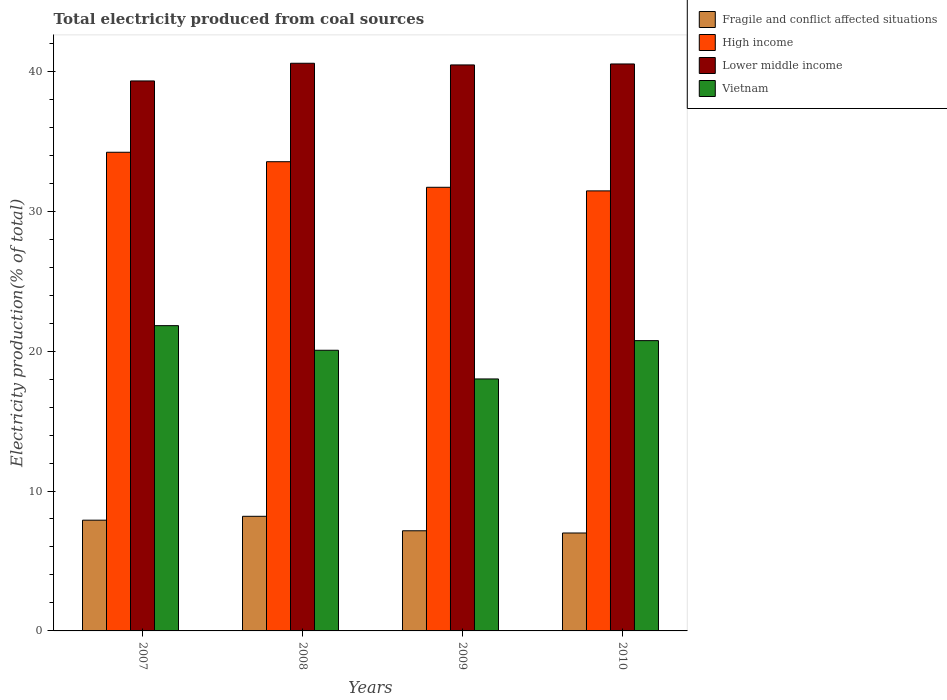How many different coloured bars are there?
Make the answer very short. 4. Are the number of bars per tick equal to the number of legend labels?
Your answer should be very brief. Yes. How many bars are there on the 3rd tick from the right?
Your response must be concise. 4. What is the label of the 2nd group of bars from the left?
Make the answer very short. 2008. In how many cases, is the number of bars for a given year not equal to the number of legend labels?
Your answer should be very brief. 0. What is the total electricity produced in Vietnam in 2009?
Your response must be concise. 18.01. Across all years, what is the maximum total electricity produced in Fragile and conflict affected situations?
Your response must be concise. 8.19. Across all years, what is the minimum total electricity produced in Lower middle income?
Offer a very short reply. 39.31. In which year was the total electricity produced in High income minimum?
Make the answer very short. 2010. What is the total total electricity produced in High income in the graph?
Make the answer very short. 130.9. What is the difference between the total electricity produced in Fragile and conflict affected situations in 2007 and that in 2008?
Give a very brief answer. -0.28. What is the difference between the total electricity produced in High income in 2007 and the total electricity produced in Vietnam in 2009?
Give a very brief answer. 16.2. What is the average total electricity produced in Lower middle income per year?
Your answer should be very brief. 40.21. In the year 2009, what is the difference between the total electricity produced in Fragile and conflict affected situations and total electricity produced in Vietnam?
Your answer should be very brief. -10.85. In how many years, is the total electricity produced in Fragile and conflict affected situations greater than 14 %?
Offer a very short reply. 0. What is the ratio of the total electricity produced in Vietnam in 2008 to that in 2010?
Your answer should be very brief. 0.97. What is the difference between the highest and the second highest total electricity produced in High income?
Provide a short and direct response. 0.68. What is the difference between the highest and the lowest total electricity produced in High income?
Make the answer very short. 2.76. What does the 4th bar from the left in 2007 represents?
Provide a short and direct response. Vietnam. What does the 3rd bar from the right in 2008 represents?
Provide a succinct answer. High income. Is it the case that in every year, the sum of the total electricity produced in Fragile and conflict affected situations and total electricity produced in Lower middle income is greater than the total electricity produced in Vietnam?
Your answer should be compact. Yes. How many bars are there?
Your response must be concise. 16. Are all the bars in the graph horizontal?
Offer a very short reply. No. How many years are there in the graph?
Your answer should be very brief. 4. What is the difference between two consecutive major ticks on the Y-axis?
Offer a very short reply. 10. Are the values on the major ticks of Y-axis written in scientific E-notation?
Ensure brevity in your answer.  No. Does the graph contain any zero values?
Keep it short and to the point. No. How many legend labels are there?
Offer a terse response. 4. How are the legend labels stacked?
Your response must be concise. Vertical. What is the title of the graph?
Offer a terse response. Total electricity produced from coal sources. What is the label or title of the X-axis?
Offer a terse response. Years. What is the label or title of the Y-axis?
Offer a terse response. Electricity production(% of total). What is the Electricity production(% of total) of Fragile and conflict affected situations in 2007?
Ensure brevity in your answer.  7.91. What is the Electricity production(% of total) in High income in 2007?
Provide a succinct answer. 34.21. What is the Electricity production(% of total) in Lower middle income in 2007?
Keep it short and to the point. 39.31. What is the Electricity production(% of total) in Vietnam in 2007?
Your answer should be very brief. 21.82. What is the Electricity production(% of total) in Fragile and conflict affected situations in 2008?
Offer a very short reply. 8.19. What is the Electricity production(% of total) in High income in 2008?
Your response must be concise. 33.54. What is the Electricity production(% of total) of Lower middle income in 2008?
Ensure brevity in your answer.  40.57. What is the Electricity production(% of total) in Vietnam in 2008?
Your answer should be very brief. 20.06. What is the Electricity production(% of total) in Fragile and conflict affected situations in 2009?
Your response must be concise. 7.16. What is the Electricity production(% of total) of High income in 2009?
Your answer should be very brief. 31.71. What is the Electricity production(% of total) in Lower middle income in 2009?
Make the answer very short. 40.45. What is the Electricity production(% of total) of Vietnam in 2009?
Offer a terse response. 18.01. What is the Electricity production(% of total) in Fragile and conflict affected situations in 2010?
Give a very brief answer. 7. What is the Electricity production(% of total) of High income in 2010?
Provide a short and direct response. 31.45. What is the Electricity production(% of total) in Lower middle income in 2010?
Provide a short and direct response. 40.52. What is the Electricity production(% of total) in Vietnam in 2010?
Offer a terse response. 20.75. Across all years, what is the maximum Electricity production(% of total) in Fragile and conflict affected situations?
Your answer should be very brief. 8.19. Across all years, what is the maximum Electricity production(% of total) of High income?
Your response must be concise. 34.21. Across all years, what is the maximum Electricity production(% of total) in Lower middle income?
Ensure brevity in your answer.  40.57. Across all years, what is the maximum Electricity production(% of total) in Vietnam?
Offer a very short reply. 21.82. Across all years, what is the minimum Electricity production(% of total) in Fragile and conflict affected situations?
Keep it short and to the point. 7. Across all years, what is the minimum Electricity production(% of total) of High income?
Your answer should be very brief. 31.45. Across all years, what is the minimum Electricity production(% of total) in Lower middle income?
Your answer should be very brief. 39.31. Across all years, what is the minimum Electricity production(% of total) in Vietnam?
Make the answer very short. 18.01. What is the total Electricity production(% of total) of Fragile and conflict affected situations in the graph?
Your answer should be compact. 30.26. What is the total Electricity production(% of total) in High income in the graph?
Your answer should be compact. 130.9. What is the total Electricity production(% of total) of Lower middle income in the graph?
Give a very brief answer. 160.86. What is the total Electricity production(% of total) of Vietnam in the graph?
Ensure brevity in your answer.  80.63. What is the difference between the Electricity production(% of total) of Fragile and conflict affected situations in 2007 and that in 2008?
Offer a very short reply. -0.28. What is the difference between the Electricity production(% of total) in High income in 2007 and that in 2008?
Offer a very short reply. 0.68. What is the difference between the Electricity production(% of total) in Lower middle income in 2007 and that in 2008?
Your answer should be compact. -1.26. What is the difference between the Electricity production(% of total) of Vietnam in 2007 and that in 2008?
Offer a very short reply. 1.76. What is the difference between the Electricity production(% of total) in Fragile and conflict affected situations in 2007 and that in 2009?
Provide a succinct answer. 0.76. What is the difference between the Electricity production(% of total) in High income in 2007 and that in 2009?
Ensure brevity in your answer.  2.5. What is the difference between the Electricity production(% of total) in Lower middle income in 2007 and that in 2009?
Keep it short and to the point. -1.15. What is the difference between the Electricity production(% of total) of Vietnam in 2007 and that in 2009?
Offer a terse response. 3.81. What is the difference between the Electricity production(% of total) of Fragile and conflict affected situations in 2007 and that in 2010?
Offer a very short reply. 0.92. What is the difference between the Electricity production(% of total) in High income in 2007 and that in 2010?
Your answer should be compact. 2.76. What is the difference between the Electricity production(% of total) of Lower middle income in 2007 and that in 2010?
Offer a terse response. -1.21. What is the difference between the Electricity production(% of total) in Vietnam in 2007 and that in 2010?
Your answer should be very brief. 1.07. What is the difference between the Electricity production(% of total) in Fragile and conflict affected situations in 2008 and that in 2009?
Provide a short and direct response. 1.03. What is the difference between the Electricity production(% of total) in High income in 2008 and that in 2009?
Make the answer very short. 1.83. What is the difference between the Electricity production(% of total) of Lower middle income in 2008 and that in 2009?
Give a very brief answer. 0.12. What is the difference between the Electricity production(% of total) of Vietnam in 2008 and that in 2009?
Your answer should be compact. 2.05. What is the difference between the Electricity production(% of total) of Fragile and conflict affected situations in 2008 and that in 2010?
Your answer should be compact. 1.19. What is the difference between the Electricity production(% of total) of High income in 2008 and that in 2010?
Make the answer very short. 2.08. What is the difference between the Electricity production(% of total) of Lower middle income in 2008 and that in 2010?
Provide a short and direct response. 0.05. What is the difference between the Electricity production(% of total) in Vietnam in 2008 and that in 2010?
Offer a terse response. -0.69. What is the difference between the Electricity production(% of total) in Fragile and conflict affected situations in 2009 and that in 2010?
Keep it short and to the point. 0.16. What is the difference between the Electricity production(% of total) in High income in 2009 and that in 2010?
Your response must be concise. 0.26. What is the difference between the Electricity production(% of total) in Lower middle income in 2009 and that in 2010?
Your response must be concise. -0.07. What is the difference between the Electricity production(% of total) of Vietnam in 2009 and that in 2010?
Keep it short and to the point. -2.74. What is the difference between the Electricity production(% of total) in Fragile and conflict affected situations in 2007 and the Electricity production(% of total) in High income in 2008?
Your answer should be compact. -25.62. What is the difference between the Electricity production(% of total) in Fragile and conflict affected situations in 2007 and the Electricity production(% of total) in Lower middle income in 2008?
Offer a very short reply. -32.66. What is the difference between the Electricity production(% of total) in Fragile and conflict affected situations in 2007 and the Electricity production(% of total) in Vietnam in 2008?
Your answer should be very brief. -12.14. What is the difference between the Electricity production(% of total) of High income in 2007 and the Electricity production(% of total) of Lower middle income in 2008?
Your answer should be compact. -6.36. What is the difference between the Electricity production(% of total) of High income in 2007 and the Electricity production(% of total) of Vietnam in 2008?
Offer a very short reply. 14.15. What is the difference between the Electricity production(% of total) in Lower middle income in 2007 and the Electricity production(% of total) in Vietnam in 2008?
Make the answer very short. 19.25. What is the difference between the Electricity production(% of total) in Fragile and conflict affected situations in 2007 and the Electricity production(% of total) in High income in 2009?
Make the answer very short. -23.79. What is the difference between the Electricity production(% of total) of Fragile and conflict affected situations in 2007 and the Electricity production(% of total) of Lower middle income in 2009?
Make the answer very short. -32.54. What is the difference between the Electricity production(% of total) in Fragile and conflict affected situations in 2007 and the Electricity production(% of total) in Vietnam in 2009?
Your answer should be compact. -10.09. What is the difference between the Electricity production(% of total) of High income in 2007 and the Electricity production(% of total) of Lower middle income in 2009?
Your answer should be compact. -6.24. What is the difference between the Electricity production(% of total) of High income in 2007 and the Electricity production(% of total) of Vietnam in 2009?
Offer a very short reply. 16.2. What is the difference between the Electricity production(% of total) of Lower middle income in 2007 and the Electricity production(% of total) of Vietnam in 2009?
Provide a succinct answer. 21.3. What is the difference between the Electricity production(% of total) in Fragile and conflict affected situations in 2007 and the Electricity production(% of total) in High income in 2010?
Provide a succinct answer. -23.54. What is the difference between the Electricity production(% of total) of Fragile and conflict affected situations in 2007 and the Electricity production(% of total) of Lower middle income in 2010?
Your answer should be very brief. -32.61. What is the difference between the Electricity production(% of total) in Fragile and conflict affected situations in 2007 and the Electricity production(% of total) in Vietnam in 2010?
Provide a short and direct response. -12.83. What is the difference between the Electricity production(% of total) of High income in 2007 and the Electricity production(% of total) of Lower middle income in 2010?
Provide a succinct answer. -6.31. What is the difference between the Electricity production(% of total) in High income in 2007 and the Electricity production(% of total) in Vietnam in 2010?
Give a very brief answer. 13.46. What is the difference between the Electricity production(% of total) of Lower middle income in 2007 and the Electricity production(% of total) of Vietnam in 2010?
Keep it short and to the point. 18.56. What is the difference between the Electricity production(% of total) in Fragile and conflict affected situations in 2008 and the Electricity production(% of total) in High income in 2009?
Make the answer very short. -23.52. What is the difference between the Electricity production(% of total) of Fragile and conflict affected situations in 2008 and the Electricity production(% of total) of Lower middle income in 2009?
Your response must be concise. -32.26. What is the difference between the Electricity production(% of total) in Fragile and conflict affected situations in 2008 and the Electricity production(% of total) in Vietnam in 2009?
Provide a short and direct response. -9.82. What is the difference between the Electricity production(% of total) of High income in 2008 and the Electricity production(% of total) of Lower middle income in 2009?
Keep it short and to the point. -6.92. What is the difference between the Electricity production(% of total) of High income in 2008 and the Electricity production(% of total) of Vietnam in 2009?
Your answer should be compact. 15.53. What is the difference between the Electricity production(% of total) in Lower middle income in 2008 and the Electricity production(% of total) in Vietnam in 2009?
Offer a very short reply. 22.56. What is the difference between the Electricity production(% of total) in Fragile and conflict affected situations in 2008 and the Electricity production(% of total) in High income in 2010?
Offer a terse response. -23.26. What is the difference between the Electricity production(% of total) in Fragile and conflict affected situations in 2008 and the Electricity production(% of total) in Lower middle income in 2010?
Your answer should be very brief. -32.33. What is the difference between the Electricity production(% of total) of Fragile and conflict affected situations in 2008 and the Electricity production(% of total) of Vietnam in 2010?
Ensure brevity in your answer.  -12.56. What is the difference between the Electricity production(% of total) in High income in 2008 and the Electricity production(% of total) in Lower middle income in 2010?
Provide a short and direct response. -6.99. What is the difference between the Electricity production(% of total) of High income in 2008 and the Electricity production(% of total) of Vietnam in 2010?
Your answer should be very brief. 12.79. What is the difference between the Electricity production(% of total) in Lower middle income in 2008 and the Electricity production(% of total) in Vietnam in 2010?
Your response must be concise. 19.82. What is the difference between the Electricity production(% of total) in Fragile and conflict affected situations in 2009 and the Electricity production(% of total) in High income in 2010?
Give a very brief answer. -24.29. What is the difference between the Electricity production(% of total) of Fragile and conflict affected situations in 2009 and the Electricity production(% of total) of Lower middle income in 2010?
Give a very brief answer. -33.36. What is the difference between the Electricity production(% of total) of Fragile and conflict affected situations in 2009 and the Electricity production(% of total) of Vietnam in 2010?
Make the answer very short. -13.59. What is the difference between the Electricity production(% of total) of High income in 2009 and the Electricity production(% of total) of Lower middle income in 2010?
Your response must be concise. -8.81. What is the difference between the Electricity production(% of total) of High income in 2009 and the Electricity production(% of total) of Vietnam in 2010?
Your answer should be compact. 10.96. What is the difference between the Electricity production(% of total) of Lower middle income in 2009 and the Electricity production(% of total) of Vietnam in 2010?
Your answer should be very brief. 19.71. What is the average Electricity production(% of total) in Fragile and conflict affected situations per year?
Offer a terse response. 7.57. What is the average Electricity production(% of total) of High income per year?
Provide a succinct answer. 32.73. What is the average Electricity production(% of total) of Lower middle income per year?
Make the answer very short. 40.21. What is the average Electricity production(% of total) in Vietnam per year?
Your response must be concise. 20.16. In the year 2007, what is the difference between the Electricity production(% of total) of Fragile and conflict affected situations and Electricity production(% of total) of High income?
Your answer should be very brief. -26.3. In the year 2007, what is the difference between the Electricity production(% of total) in Fragile and conflict affected situations and Electricity production(% of total) in Lower middle income?
Give a very brief answer. -31.39. In the year 2007, what is the difference between the Electricity production(% of total) in Fragile and conflict affected situations and Electricity production(% of total) in Vietnam?
Keep it short and to the point. -13.9. In the year 2007, what is the difference between the Electricity production(% of total) in High income and Electricity production(% of total) in Lower middle income?
Provide a short and direct response. -5.1. In the year 2007, what is the difference between the Electricity production(% of total) of High income and Electricity production(% of total) of Vietnam?
Ensure brevity in your answer.  12.39. In the year 2007, what is the difference between the Electricity production(% of total) of Lower middle income and Electricity production(% of total) of Vietnam?
Give a very brief answer. 17.49. In the year 2008, what is the difference between the Electricity production(% of total) in Fragile and conflict affected situations and Electricity production(% of total) in High income?
Provide a succinct answer. -25.34. In the year 2008, what is the difference between the Electricity production(% of total) of Fragile and conflict affected situations and Electricity production(% of total) of Lower middle income?
Make the answer very short. -32.38. In the year 2008, what is the difference between the Electricity production(% of total) in Fragile and conflict affected situations and Electricity production(% of total) in Vietnam?
Make the answer very short. -11.87. In the year 2008, what is the difference between the Electricity production(% of total) in High income and Electricity production(% of total) in Lower middle income?
Keep it short and to the point. -7.04. In the year 2008, what is the difference between the Electricity production(% of total) of High income and Electricity production(% of total) of Vietnam?
Provide a succinct answer. 13.48. In the year 2008, what is the difference between the Electricity production(% of total) in Lower middle income and Electricity production(% of total) in Vietnam?
Make the answer very short. 20.51. In the year 2009, what is the difference between the Electricity production(% of total) of Fragile and conflict affected situations and Electricity production(% of total) of High income?
Keep it short and to the point. -24.55. In the year 2009, what is the difference between the Electricity production(% of total) of Fragile and conflict affected situations and Electricity production(% of total) of Lower middle income?
Your answer should be compact. -33.3. In the year 2009, what is the difference between the Electricity production(% of total) in Fragile and conflict affected situations and Electricity production(% of total) in Vietnam?
Ensure brevity in your answer.  -10.85. In the year 2009, what is the difference between the Electricity production(% of total) in High income and Electricity production(% of total) in Lower middle income?
Offer a very short reply. -8.75. In the year 2009, what is the difference between the Electricity production(% of total) of High income and Electricity production(% of total) of Vietnam?
Provide a succinct answer. 13.7. In the year 2009, what is the difference between the Electricity production(% of total) in Lower middle income and Electricity production(% of total) in Vietnam?
Your response must be concise. 22.44. In the year 2010, what is the difference between the Electricity production(% of total) of Fragile and conflict affected situations and Electricity production(% of total) of High income?
Offer a very short reply. -24.45. In the year 2010, what is the difference between the Electricity production(% of total) in Fragile and conflict affected situations and Electricity production(% of total) in Lower middle income?
Your response must be concise. -33.52. In the year 2010, what is the difference between the Electricity production(% of total) in Fragile and conflict affected situations and Electricity production(% of total) in Vietnam?
Offer a terse response. -13.75. In the year 2010, what is the difference between the Electricity production(% of total) in High income and Electricity production(% of total) in Lower middle income?
Your response must be concise. -9.07. In the year 2010, what is the difference between the Electricity production(% of total) of High income and Electricity production(% of total) of Vietnam?
Make the answer very short. 10.7. In the year 2010, what is the difference between the Electricity production(% of total) of Lower middle income and Electricity production(% of total) of Vietnam?
Give a very brief answer. 19.77. What is the ratio of the Electricity production(% of total) in Fragile and conflict affected situations in 2007 to that in 2008?
Your answer should be compact. 0.97. What is the ratio of the Electricity production(% of total) of High income in 2007 to that in 2008?
Your answer should be compact. 1.02. What is the ratio of the Electricity production(% of total) in Lower middle income in 2007 to that in 2008?
Your response must be concise. 0.97. What is the ratio of the Electricity production(% of total) in Vietnam in 2007 to that in 2008?
Your response must be concise. 1.09. What is the ratio of the Electricity production(% of total) of Fragile and conflict affected situations in 2007 to that in 2009?
Keep it short and to the point. 1.11. What is the ratio of the Electricity production(% of total) of High income in 2007 to that in 2009?
Give a very brief answer. 1.08. What is the ratio of the Electricity production(% of total) in Lower middle income in 2007 to that in 2009?
Ensure brevity in your answer.  0.97. What is the ratio of the Electricity production(% of total) in Vietnam in 2007 to that in 2009?
Provide a succinct answer. 1.21. What is the ratio of the Electricity production(% of total) of Fragile and conflict affected situations in 2007 to that in 2010?
Provide a short and direct response. 1.13. What is the ratio of the Electricity production(% of total) of High income in 2007 to that in 2010?
Ensure brevity in your answer.  1.09. What is the ratio of the Electricity production(% of total) of Lower middle income in 2007 to that in 2010?
Ensure brevity in your answer.  0.97. What is the ratio of the Electricity production(% of total) of Vietnam in 2007 to that in 2010?
Give a very brief answer. 1.05. What is the ratio of the Electricity production(% of total) in Fragile and conflict affected situations in 2008 to that in 2009?
Make the answer very short. 1.14. What is the ratio of the Electricity production(% of total) of High income in 2008 to that in 2009?
Your answer should be very brief. 1.06. What is the ratio of the Electricity production(% of total) in Vietnam in 2008 to that in 2009?
Make the answer very short. 1.11. What is the ratio of the Electricity production(% of total) of Fragile and conflict affected situations in 2008 to that in 2010?
Your response must be concise. 1.17. What is the ratio of the Electricity production(% of total) in High income in 2008 to that in 2010?
Your response must be concise. 1.07. What is the ratio of the Electricity production(% of total) of Lower middle income in 2008 to that in 2010?
Your answer should be very brief. 1. What is the ratio of the Electricity production(% of total) of Vietnam in 2008 to that in 2010?
Offer a terse response. 0.97. What is the ratio of the Electricity production(% of total) in Fragile and conflict affected situations in 2009 to that in 2010?
Offer a very short reply. 1.02. What is the ratio of the Electricity production(% of total) in High income in 2009 to that in 2010?
Provide a succinct answer. 1.01. What is the ratio of the Electricity production(% of total) in Vietnam in 2009 to that in 2010?
Give a very brief answer. 0.87. What is the difference between the highest and the second highest Electricity production(% of total) in Fragile and conflict affected situations?
Your answer should be very brief. 0.28. What is the difference between the highest and the second highest Electricity production(% of total) in High income?
Your answer should be compact. 0.68. What is the difference between the highest and the second highest Electricity production(% of total) in Lower middle income?
Your answer should be compact. 0.05. What is the difference between the highest and the second highest Electricity production(% of total) in Vietnam?
Provide a short and direct response. 1.07. What is the difference between the highest and the lowest Electricity production(% of total) of Fragile and conflict affected situations?
Offer a very short reply. 1.19. What is the difference between the highest and the lowest Electricity production(% of total) of High income?
Keep it short and to the point. 2.76. What is the difference between the highest and the lowest Electricity production(% of total) of Lower middle income?
Your response must be concise. 1.26. What is the difference between the highest and the lowest Electricity production(% of total) of Vietnam?
Make the answer very short. 3.81. 